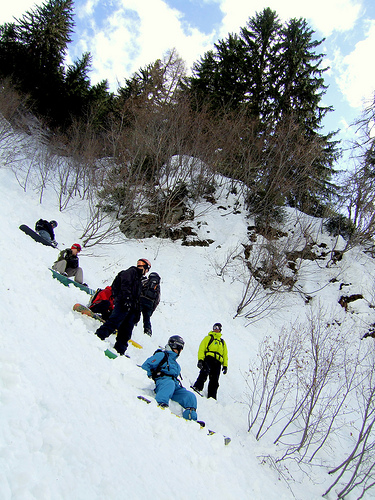<image>
Is the helmet on the snowboarder? Yes. Looking at the image, I can see the helmet is positioned on top of the snowboarder, with the snowboarder providing support. 